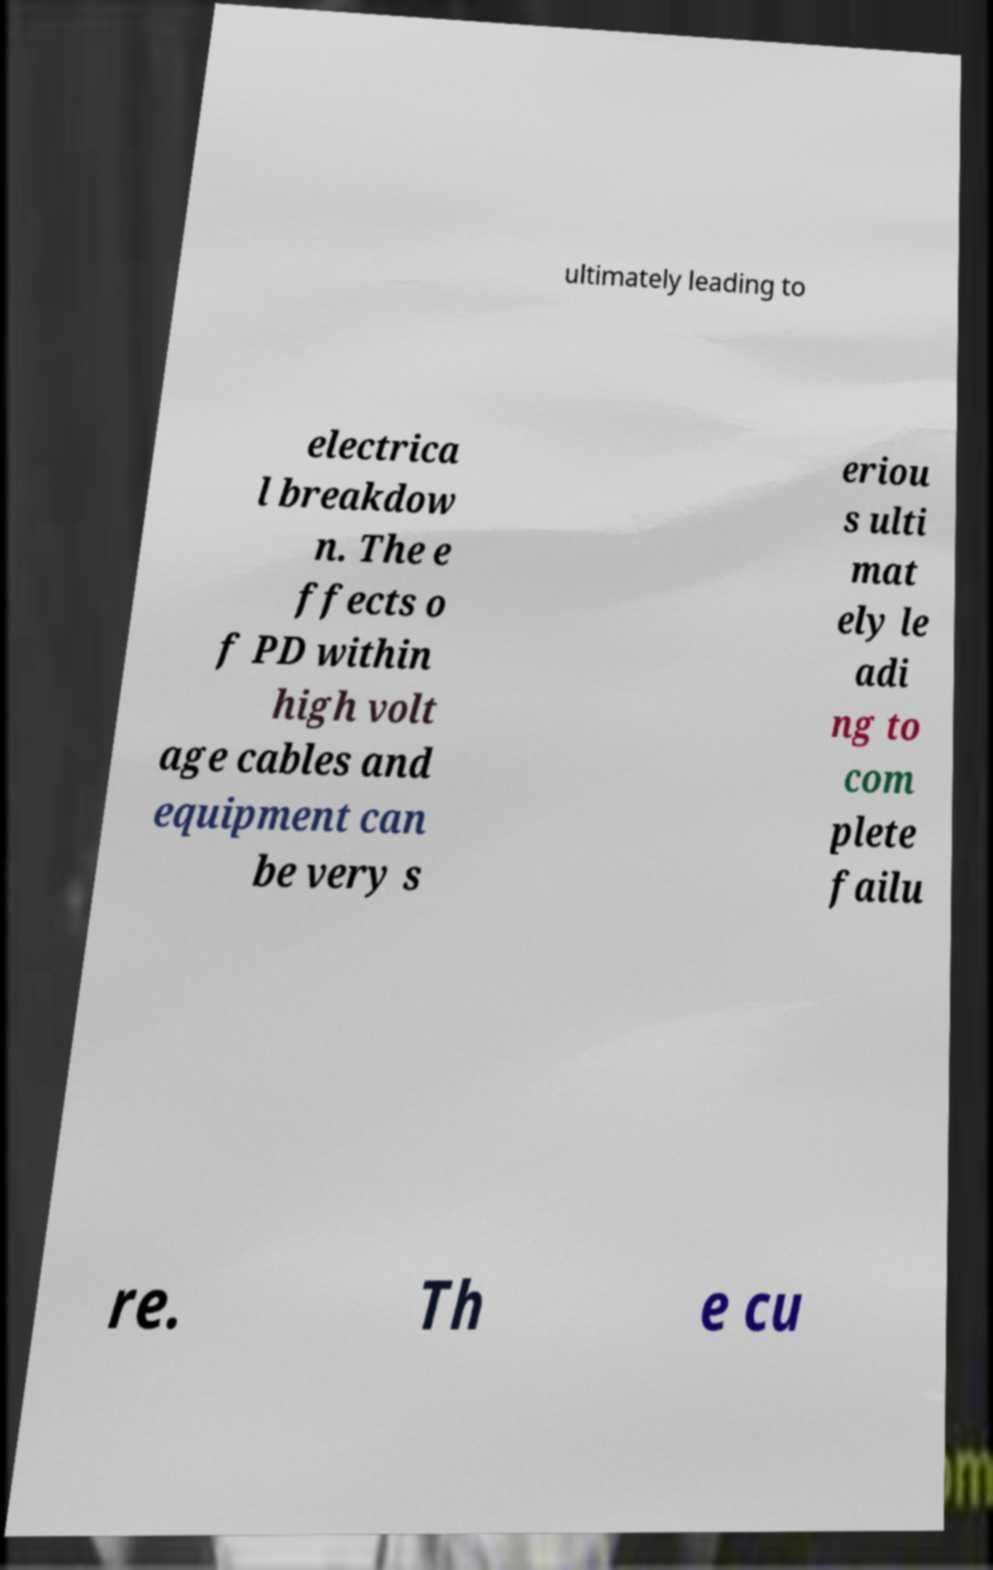What messages or text are displayed in this image? I need them in a readable, typed format. ultimately leading to electrica l breakdow n. The e ffects o f PD within high volt age cables and equipment can be very s eriou s ulti mat ely le adi ng to com plete failu re. Th e cu 